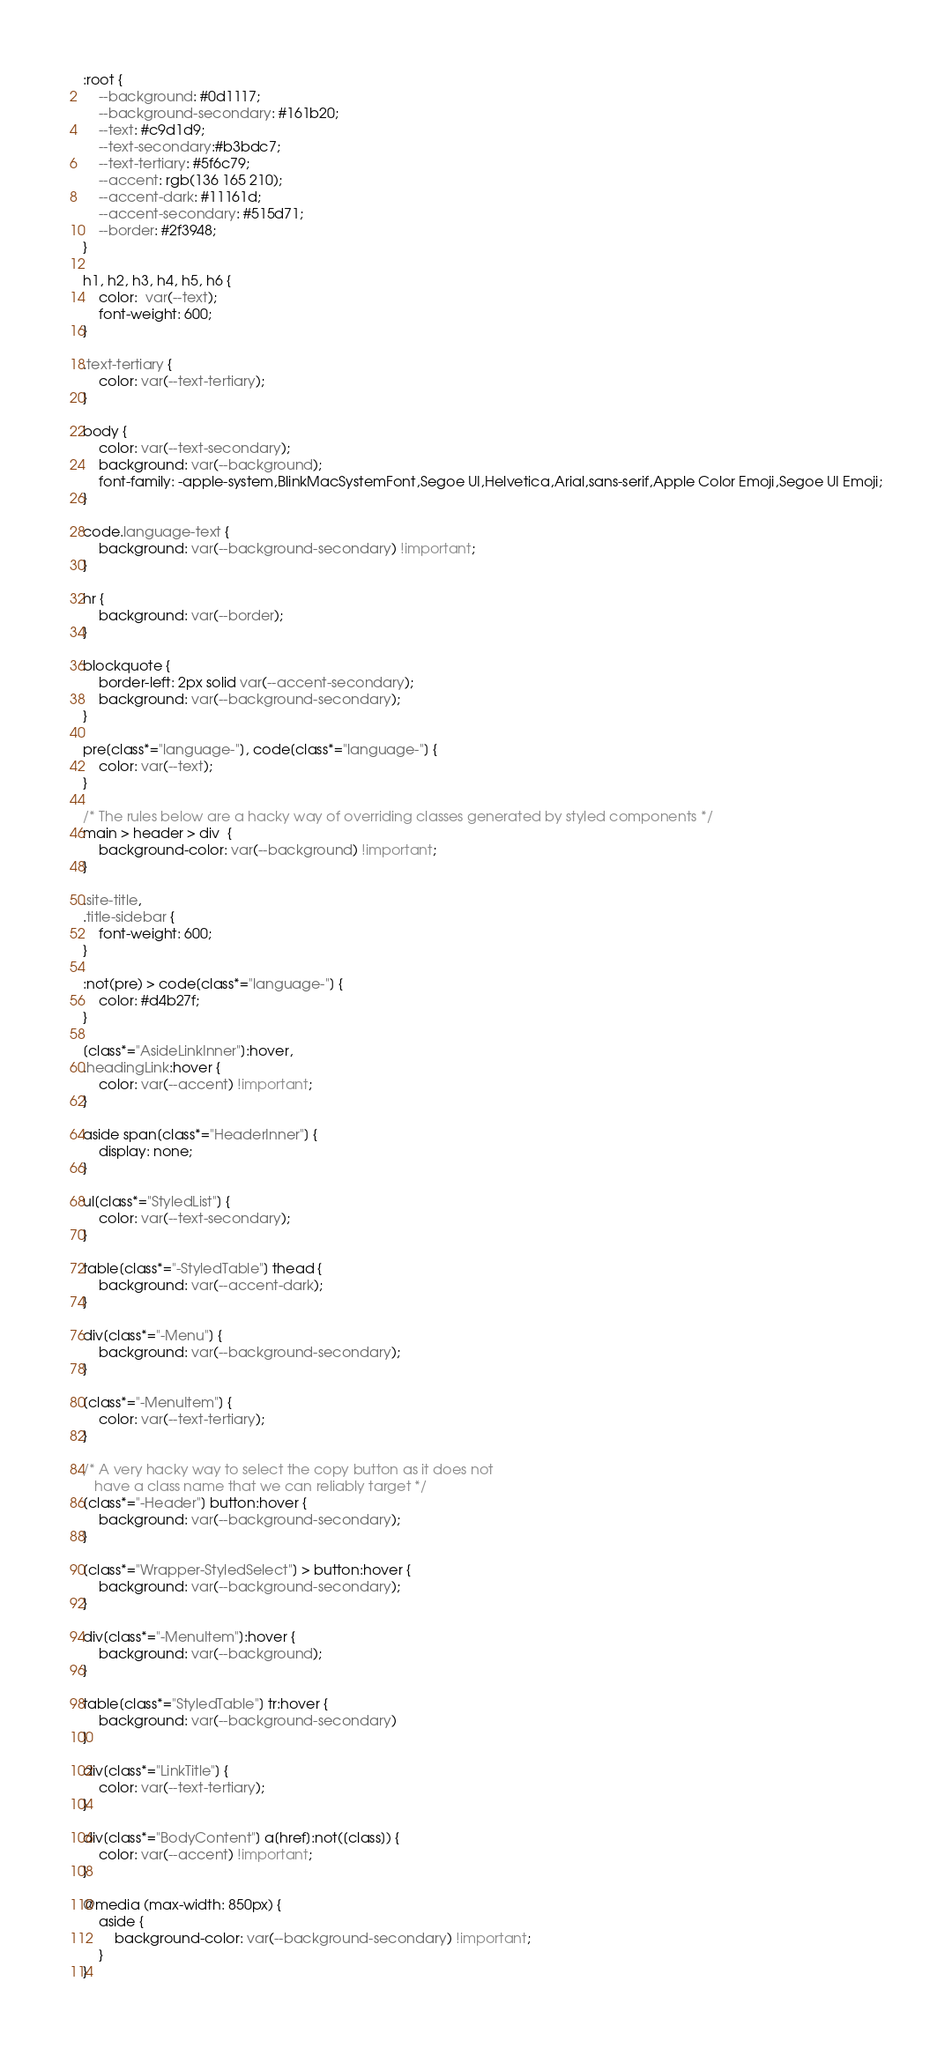<code> <loc_0><loc_0><loc_500><loc_500><_CSS_>:root {
    --background: #0d1117;
    --background-secondary: #161b20;
    --text: #c9d1d9;
    --text-secondary:#b3bdc7;
    --text-tertiary: #5f6c79;
    --accent: rgb(136 165 210);
    --accent-dark: #11161d;
    --accent-secondary: #515d71;
    --border: #2f3948;
}

h1, h2, h3, h4, h5, h6 {
    color:  var(--text);
    font-weight: 600;
} 

.text-tertiary {
    color: var(--text-tertiary);
}

body {
    color: var(--text-secondary);
    background: var(--background);
    font-family: -apple-system,BlinkMacSystemFont,Segoe UI,Helvetica,Arial,sans-serif,Apple Color Emoji,Segoe UI Emoji;
}

code.language-text {
    background: var(--background-secondary) !important;
}

hr {
    background: var(--border);
}

blockquote {
    border-left: 2px solid var(--accent-secondary);
    background: var(--background-secondary);
}

pre[class*="language-"], code[class*="language-"] {
    color: var(--text);
}

/* The rules below are a hacky way of overriding classes generated by styled components */
main > header > div  {
    background-color: var(--background) !important;
}

.site-title,
.title-sidebar {
    font-weight: 600;
} 

:not(pre) > code[class*="language-"] {
    color: #d4b27f;
}

[class*="AsideLinkInner"]:hover,
.headingLink:hover {
    color: var(--accent) !important;
}

aside span[class*="HeaderInner"] {
    display: none;
}

ul[class*="StyledList"] {
    color: var(--text-secondary);
}

table[class*="-StyledTable"] thead {
    background: var(--accent-dark);
}

div[class*="-Menu"] {
    background: var(--background-secondary);
}

[class*="-MenuItem"] {
    color: var(--text-tertiary);
}

/* A very hacky way to select the copy button as it does not
   have a class name that we can reliably target */
[class*="-Header"] button:hover {
    background: var(--background-secondary);
}

[class*="Wrapper-StyledSelect"] > button:hover {
    background: var(--background-secondary);
}

div[class*="-MenuItem"]:hover {
    background: var(--background);
}

table[class*="StyledTable"] tr:hover {
    background: var(--background-secondary)
}

div[class*="LinkTitle"] {
    color: var(--text-tertiary);
}

div[class*="BodyContent"] a[href]:not([class]) {
    color: var(--accent) !important;
}

@media (max-width: 850px) {
    aside {
        background-color: var(--background-secondary) !important;
    }
}

</code> 